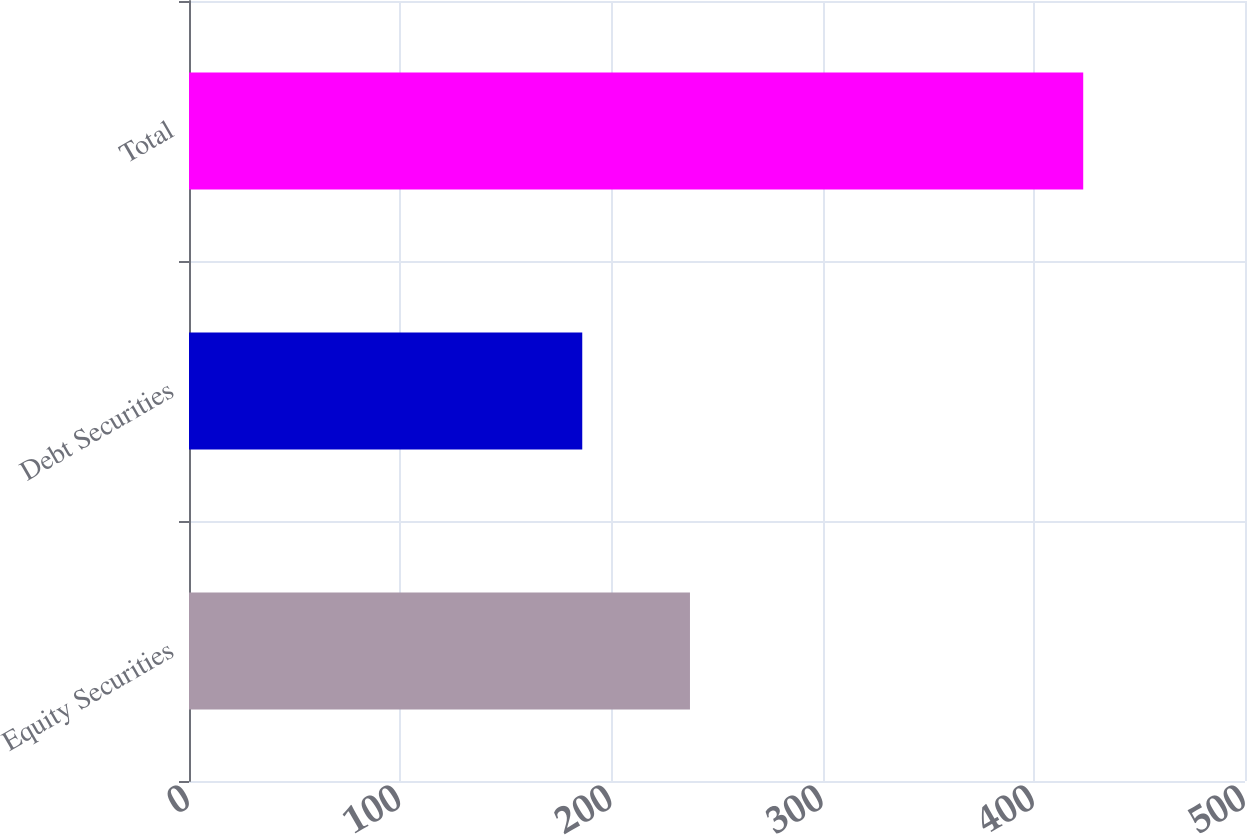Convert chart. <chart><loc_0><loc_0><loc_500><loc_500><bar_chart><fcel>Equity Securities<fcel>Debt Securities<fcel>Total<nl><fcel>237.2<fcel>186.2<fcel>423.4<nl></chart> 